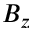<formula> <loc_0><loc_0><loc_500><loc_500>B _ { z }</formula> 